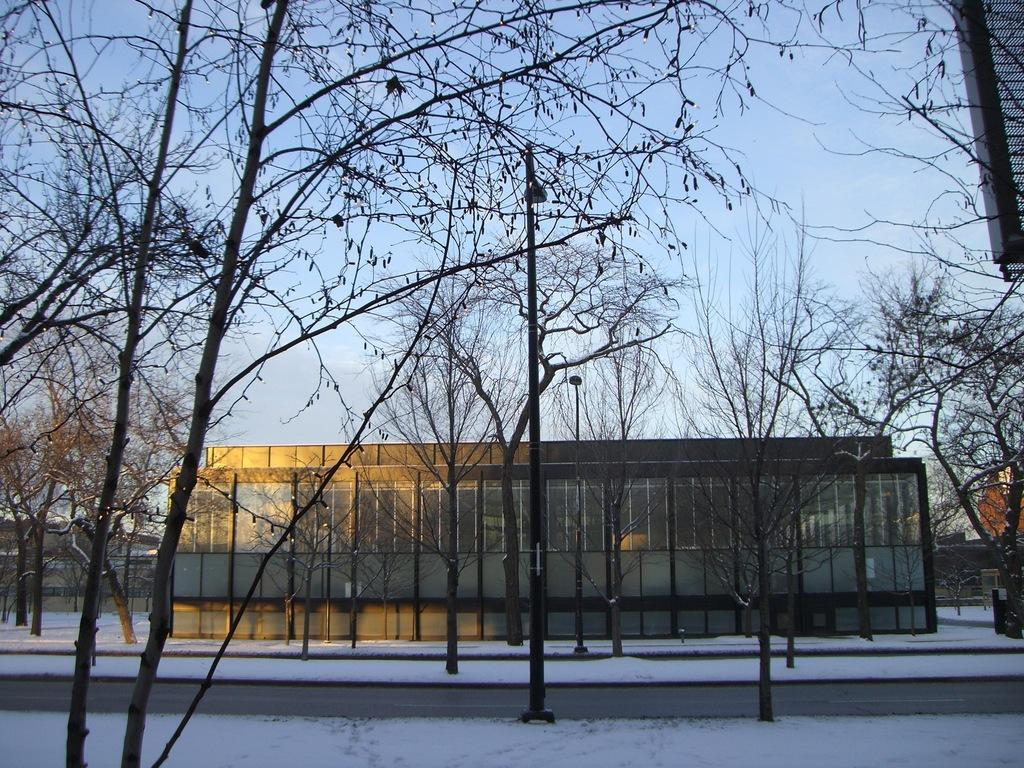What is the main feature of the image? There is a road in the image. What is the weather condition in the image? There is snow in the image. What type of vegetation can be seen in the image? There are trees in the image. What structures are present in the image? There are light poles and buildings in the image. What is visible in the background of the image? The sky is visible in the background of the image. Where is the tray located in the image? There is no tray present in the image. Who is the expert in the image? There is no expert depicted in the image. 